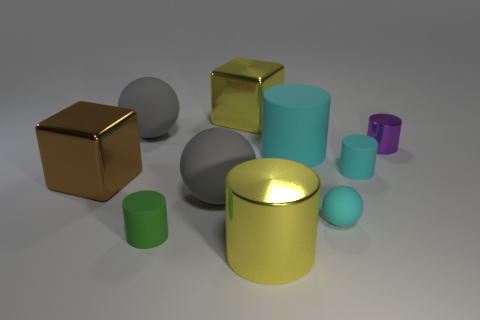Are there more gray matte things that are in front of the purple cylinder than blue objects? Comparing the objects in the image, the number of gray matte items in front of the purple cylinder does exceed the total count of blue objects present in the scene. 